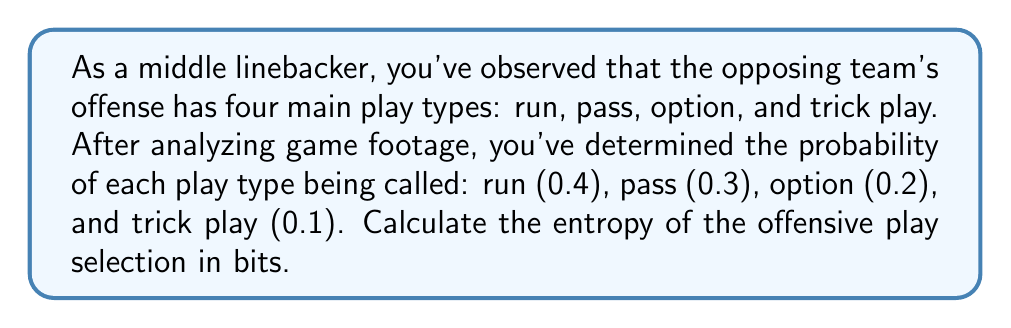Could you help me with this problem? To solve this problem, we'll use the formula for entropy in information theory, which is analogous to entropy in statistical mechanics:

$$S = -\sum_{i} p_i \log_2(p_i)$$

Where $S$ is the entropy, $p_i$ is the probability of each outcome, and the sum is taken over all possible outcomes.

Step 1: Identify the probabilities for each play type:
$p_1 = 0.4$ (run)
$p_2 = 0.3$ (pass)
$p_3 = 0.2$ (option)
$p_4 = 0.1$ (trick play)

Step 2: Calculate each term in the sum:
$-p_1 \log_2(p_1) = -0.4 \log_2(0.4) \approx 0.5288$
$-p_2 \log_2(p_2) = -0.3 \log_2(0.3) \approx 0.5211$
$-p_3 \log_2(p_3) = -0.2 \log_2(0.2) \approx 0.4644$
$-p_4 \log_2(p_4) = -0.1 \log_2(0.1) \approx 0.3322$

Step 3: Sum all terms:
$$S = 0.5288 + 0.5211 + 0.4644 + 0.3322 = 1.8465$$

Therefore, the entropy of the offensive play selection is approximately 1.8465 bits.
Answer: 1.8465 bits 